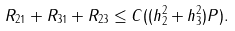<formula> <loc_0><loc_0><loc_500><loc_500>R _ { 2 1 } + R _ { 3 1 } + R _ { 2 3 } \leq C ( ( h _ { 2 } ^ { 2 } + h _ { 3 } ^ { 2 } ) P ) .</formula> 